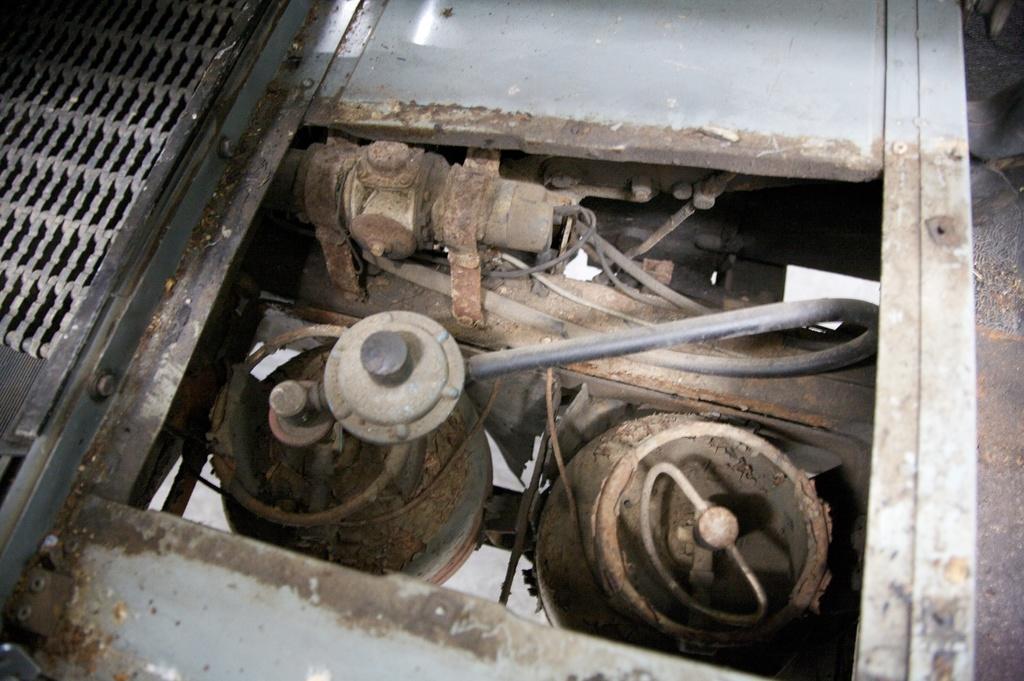How would you summarize this image in a sentence or two? In the center of the image we can see internal parts of a machine. On the left there is a mesh. 